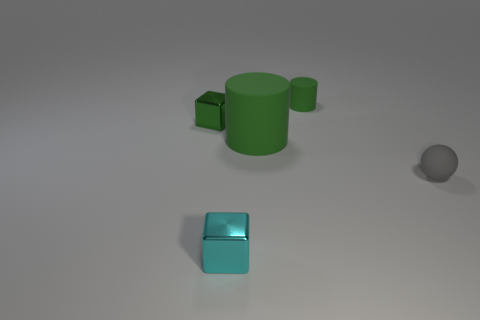Add 5 green cubes. How many objects exist? 10 Subtract all cylinders. How many objects are left? 3 Add 5 tiny green cylinders. How many tiny green cylinders are left? 6 Add 3 gray metallic things. How many gray metallic things exist? 3 Subtract 0 brown blocks. How many objects are left? 5 Subtract all small spheres. Subtract all things. How many objects are left? 3 